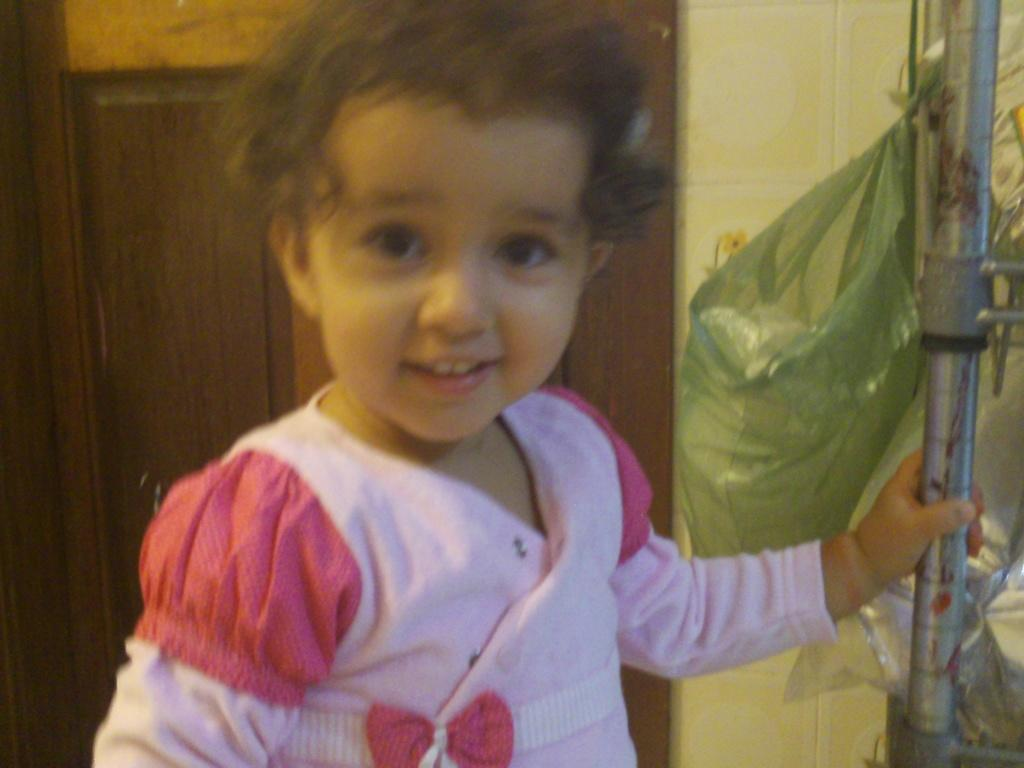What is the main subject in the foreground of the image? There is a kid in the foreground of the image. What is the kid holding in their hand? The kid is holding a metal rod in their hand. What can be seen in the background of the image? There is a door, a cover, and a wall in the background of the image. What type of location might the image be taken in? The image is likely taken in a room. What type of reaction does the girl have when she sees the brake in the image? There is no girl present in the image, and no brake is visible. 